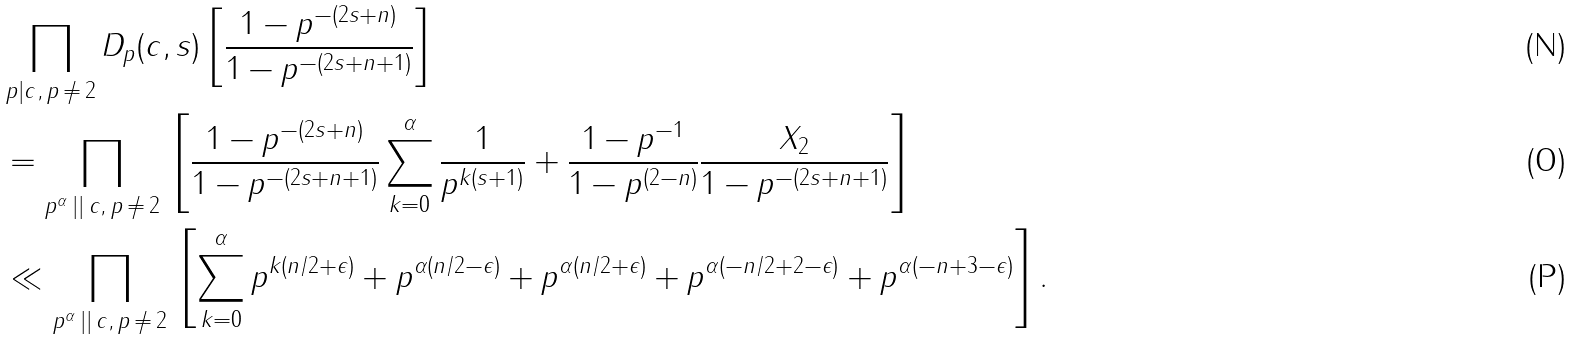<formula> <loc_0><loc_0><loc_500><loc_500>& \prod _ { p | c , \, p \, \neq \, 2 } D _ { p } ( c , s ) \left [ \frac { 1 - p ^ { - ( 2 s + n ) } } { 1 - p ^ { - ( 2 s + n + 1 ) } } \right ] \\ & = \prod _ { p ^ { \alpha } \, | | \, c , \, p \, \neq \, 2 } \, \left [ \frac { 1 - p ^ { - ( 2 s + n ) } } { 1 - p ^ { - ( 2 s + n + 1 ) } } \sum _ { k = 0 } ^ { \alpha } \frac { 1 } { p ^ { k ( s + 1 ) } } + \frac { 1 - p ^ { - 1 } } { 1 - p ^ { ( 2 - n ) } } \frac { X _ { 2 } } { 1 - p ^ { - ( 2 s + n + 1 ) } } \right ] \\ & \ll \prod _ { p ^ { \alpha } \, | | \, c , \, p \, \neq \, 2 } \, \left [ \sum _ { k = 0 } ^ { \alpha } p ^ { k ( n / 2 + \epsilon ) } + p ^ { \alpha ( n / 2 - \epsilon ) } + p ^ { \alpha ( n / 2 + \epsilon ) } + p ^ { \alpha ( - n / 2 + 2 - \epsilon ) } + p ^ { \alpha ( - n + 3 - \epsilon ) } \right ] .</formula> 